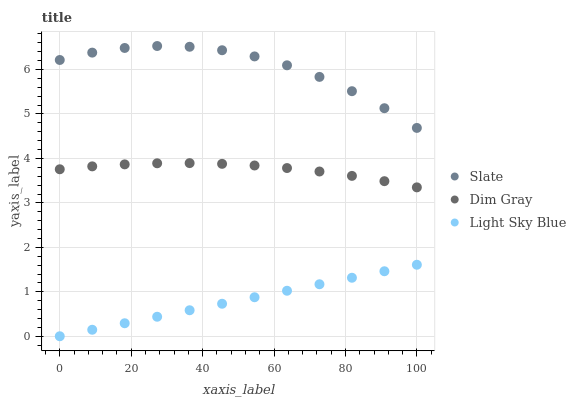Does Light Sky Blue have the minimum area under the curve?
Answer yes or no. Yes. Does Slate have the maximum area under the curve?
Answer yes or no. Yes. Does Dim Gray have the minimum area under the curve?
Answer yes or no. No. Does Dim Gray have the maximum area under the curve?
Answer yes or no. No. Is Light Sky Blue the smoothest?
Answer yes or no. Yes. Is Slate the roughest?
Answer yes or no. Yes. Is Dim Gray the smoothest?
Answer yes or no. No. Is Dim Gray the roughest?
Answer yes or no. No. Does Light Sky Blue have the lowest value?
Answer yes or no. Yes. Does Dim Gray have the lowest value?
Answer yes or no. No. Does Slate have the highest value?
Answer yes or no. Yes. Does Dim Gray have the highest value?
Answer yes or no. No. Is Dim Gray less than Slate?
Answer yes or no. Yes. Is Slate greater than Light Sky Blue?
Answer yes or no. Yes. Does Dim Gray intersect Slate?
Answer yes or no. No. 